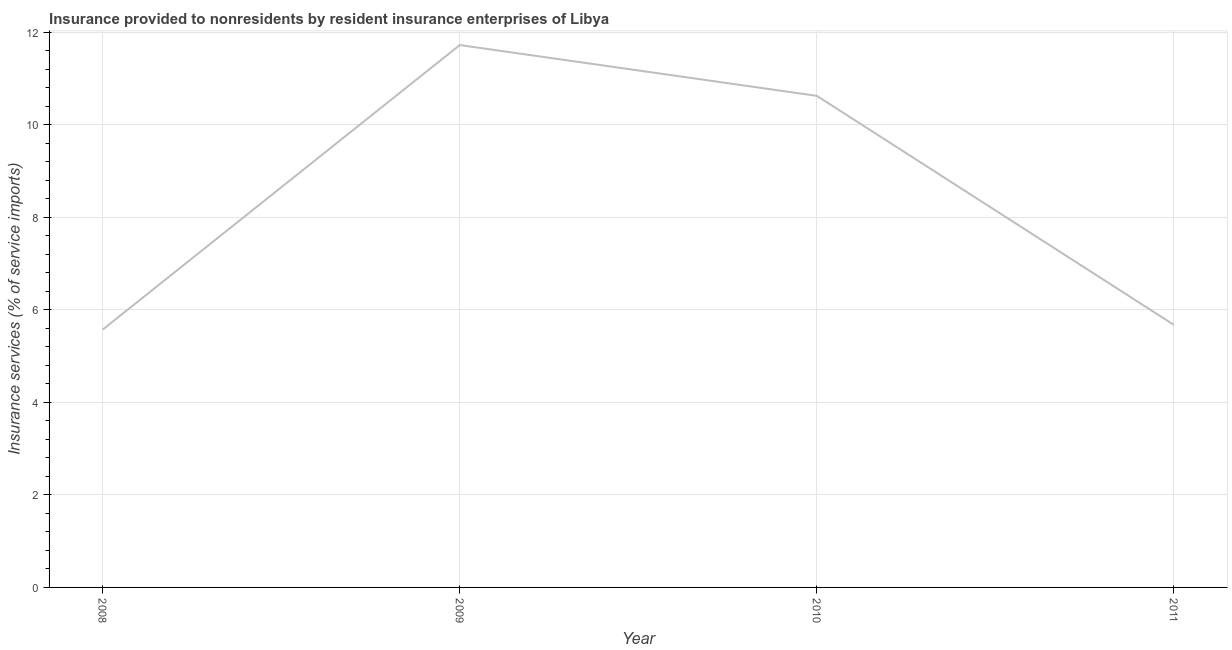What is the insurance and financial services in 2009?
Your response must be concise. 11.72. Across all years, what is the maximum insurance and financial services?
Provide a succinct answer. 11.72. Across all years, what is the minimum insurance and financial services?
Provide a succinct answer. 5.57. In which year was the insurance and financial services maximum?
Make the answer very short. 2009. What is the sum of the insurance and financial services?
Provide a short and direct response. 33.59. What is the difference between the insurance and financial services in 2008 and 2009?
Offer a very short reply. -6.15. What is the average insurance and financial services per year?
Give a very brief answer. 8.4. What is the median insurance and financial services?
Your response must be concise. 8.15. What is the ratio of the insurance and financial services in 2009 to that in 2011?
Your answer should be compact. 2.07. What is the difference between the highest and the second highest insurance and financial services?
Offer a very short reply. 1.1. What is the difference between the highest and the lowest insurance and financial services?
Make the answer very short. 6.15. In how many years, is the insurance and financial services greater than the average insurance and financial services taken over all years?
Your answer should be compact. 2. Are the values on the major ticks of Y-axis written in scientific E-notation?
Your answer should be very brief. No. Does the graph contain any zero values?
Keep it short and to the point. No. What is the title of the graph?
Provide a succinct answer. Insurance provided to nonresidents by resident insurance enterprises of Libya. What is the label or title of the Y-axis?
Keep it short and to the point. Insurance services (% of service imports). What is the Insurance services (% of service imports) in 2008?
Give a very brief answer. 5.57. What is the Insurance services (% of service imports) of 2009?
Your answer should be very brief. 11.72. What is the Insurance services (% of service imports) in 2010?
Your answer should be compact. 10.62. What is the Insurance services (% of service imports) of 2011?
Your answer should be compact. 5.67. What is the difference between the Insurance services (% of service imports) in 2008 and 2009?
Your answer should be compact. -6.15. What is the difference between the Insurance services (% of service imports) in 2008 and 2010?
Keep it short and to the point. -5.05. What is the difference between the Insurance services (% of service imports) in 2008 and 2011?
Your response must be concise. -0.1. What is the difference between the Insurance services (% of service imports) in 2009 and 2010?
Offer a terse response. 1.1. What is the difference between the Insurance services (% of service imports) in 2009 and 2011?
Ensure brevity in your answer.  6.05. What is the difference between the Insurance services (% of service imports) in 2010 and 2011?
Your answer should be very brief. 4.95. What is the ratio of the Insurance services (% of service imports) in 2008 to that in 2009?
Keep it short and to the point. 0.47. What is the ratio of the Insurance services (% of service imports) in 2008 to that in 2010?
Provide a short and direct response. 0.53. What is the ratio of the Insurance services (% of service imports) in 2009 to that in 2010?
Give a very brief answer. 1.1. What is the ratio of the Insurance services (% of service imports) in 2009 to that in 2011?
Your answer should be very brief. 2.07. What is the ratio of the Insurance services (% of service imports) in 2010 to that in 2011?
Give a very brief answer. 1.87. 